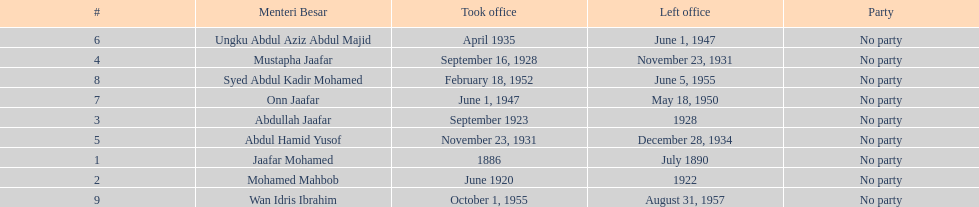Can you parse all the data within this table? {'header': ['#', 'Menteri Besar', 'Took office', 'Left office', 'Party'], 'rows': [['6', 'Ungku Abdul Aziz Abdul Majid', 'April 1935', 'June 1, 1947', 'No party'], ['4', 'Mustapha Jaafar', 'September 16, 1928', 'November 23, 1931', 'No party'], ['8', 'Syed Abdul Kadir Mohamed', 'February 18, 1952', 'June 5, 1955', 'No party'], ['7', 'Onn Jaafar', 'June 1, 1947', 'May 18, 1950', 'No party'], ['3', 'Abdullah Jaafar', 'September 1923', '1928', 'No party'], ['5', 'Abdul Hamid Yusof', 'November 23, 1931', 'December 28, 1934', 'No party'], ['1', 'Jaafar Mohamed', '1886', 'July 1890', 'No party'], ['2', 'Mohamed Mahbob', 'June 1920', '1922', 'No party'], ['9', 'Wan Idris Ibrahim', 'October 1, 1955', 'August 31, 1957', 'No party']]} Who spend the most amount of time in office? Ungku Abdul Aziz Abdul Majid. 